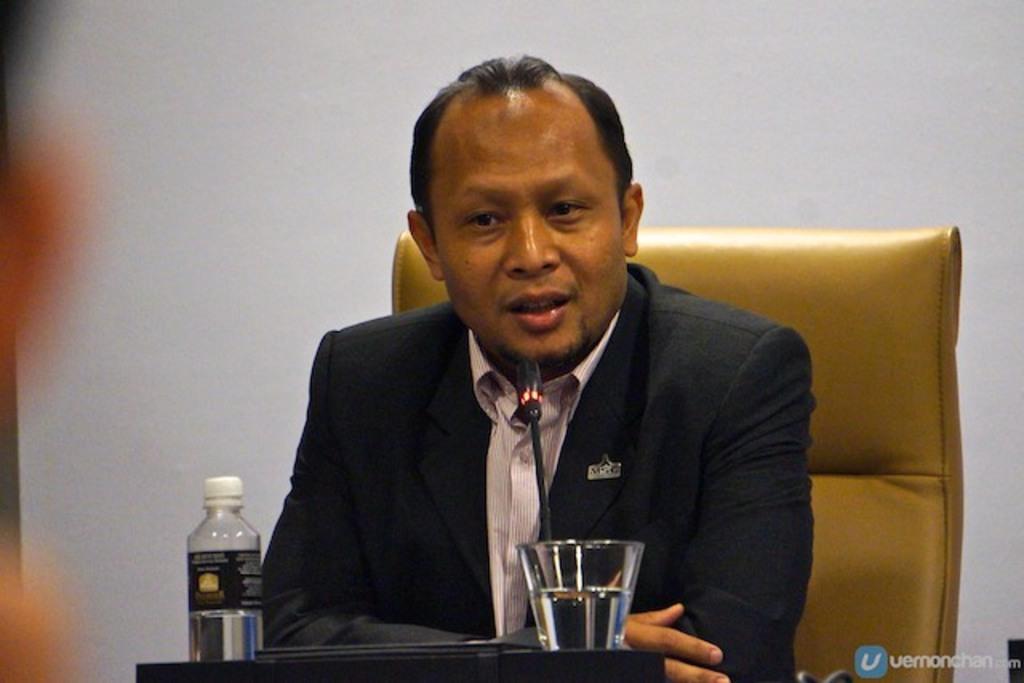Please provide a concise description of this image. In this image we can see a man sitting on a chair. At the bottom of the image we can see a bottle and a glass which are placed on the surface. On the backside we can see a wall. 